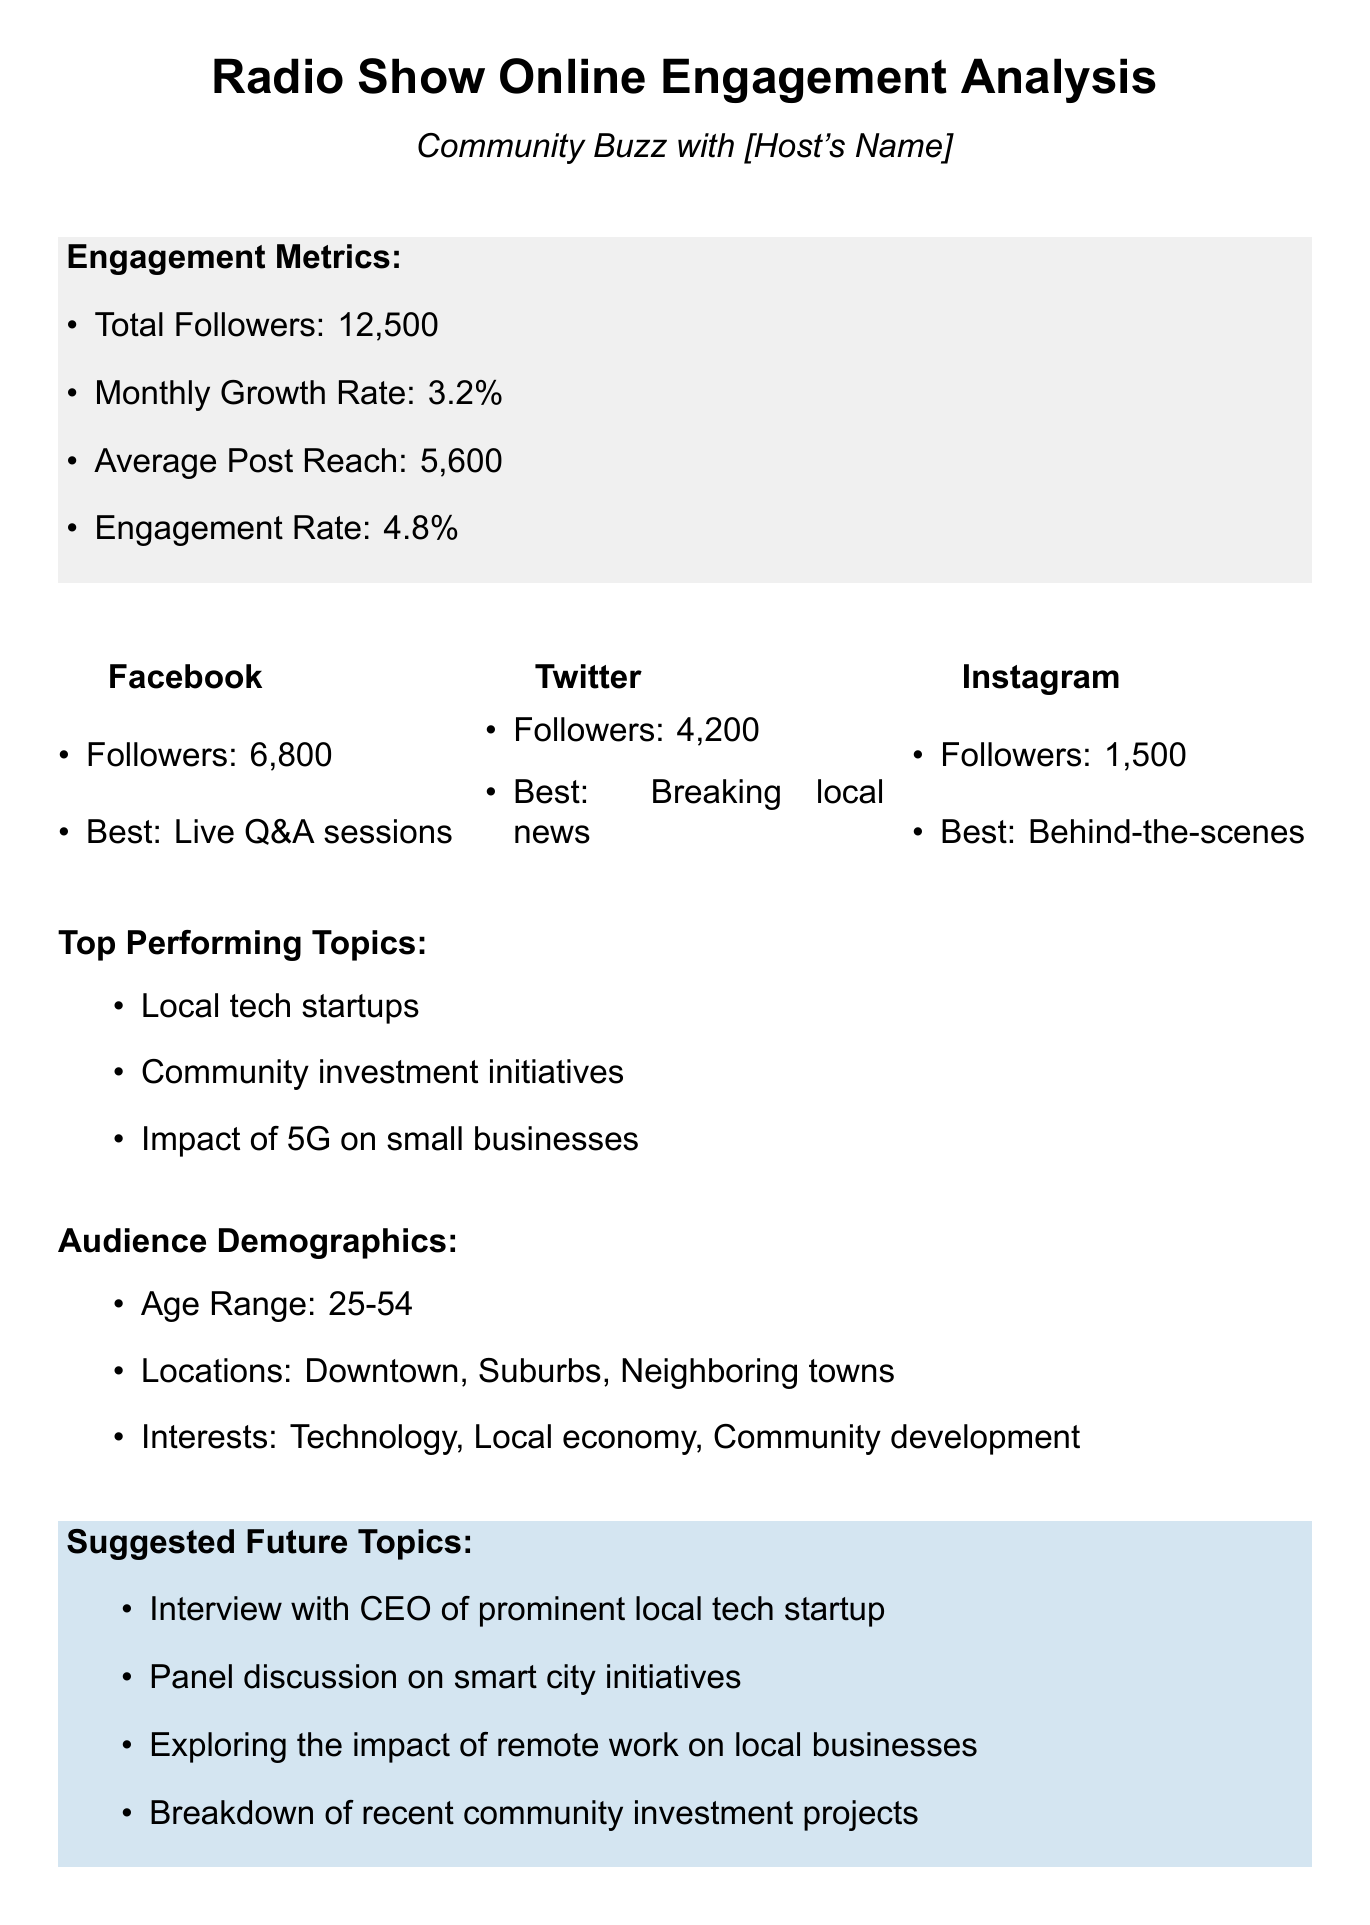What is the report title? The report title is explicitly stated in the document as the main heading.
Answer: Radio Show Online Engagement Analysis What is the date of the report? The date appears in the report header, clearly indicating when the report was created.
Answer: May 15, 2023 How many total followers does the show have? The total number of followers is provided in the engagement metrics section.
Answer: 12,500 What is the average post reach? The average post reach is listed under engagement metrics, indicating how far posts reach the audience.
Answer: 5,600 Which platform has the most followers? The platform breakdown section details the followers for each platform, allowing for comparison.
Answer: Facebook What is the most engaging content on Twitter? The document specifies the type of content that generates the most engagement for each platform.
Answer: Breaking local news updates What age range does the audience predominantly fall into? The audience demographics section provides the age range of listeners.
Answer: 25-54 Which topic is suggested for a future broadcast? Suggestions for future topics are listed in a defined section to inspire upcoming shows.
Answer: Interview with CEO of prominent local tech startup What improvement tip is provided for engagement? The document lists various tips for enhancing listener engagement, highlighting actionable items.
Answer: Increase frequency of live social media interactions 